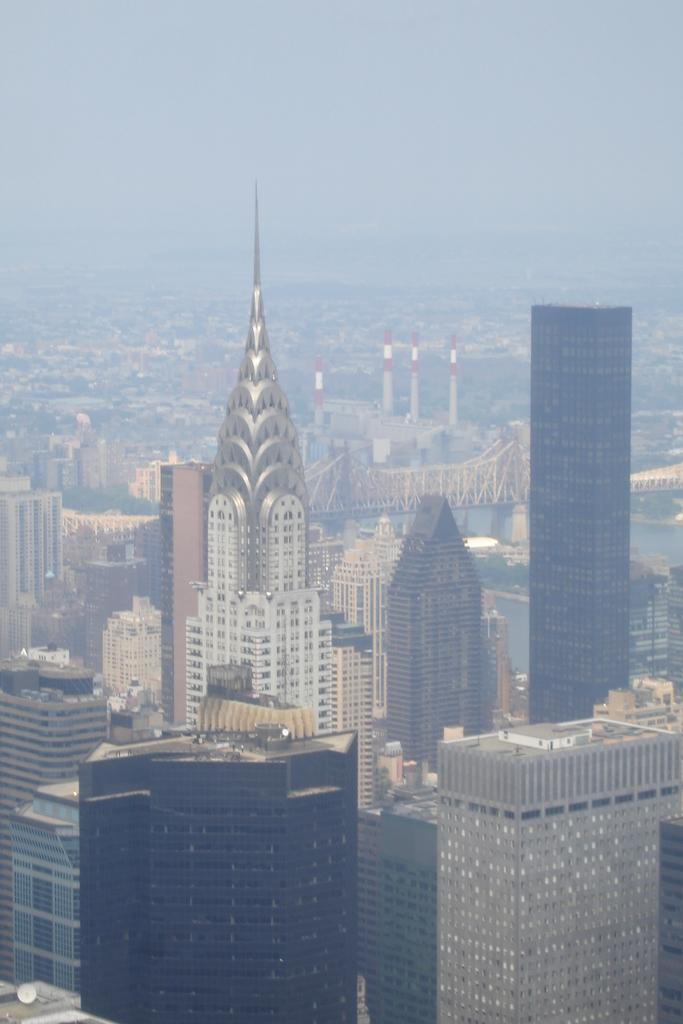What type of structures are visible in the image? There is a group of buildings with windows in the image. What can be seen in the center of the image? There is a bridge and towers in the center of the image. What is present in the center of the image along with the bridge and towers? There is water in the center of the image. What is visible at the top of the image? The sky is visible at the top of the image. What type of pest can be seen crawling on the buildings in the image? There is no pest visible in the image; the buildings are not infested with any creatures. How does the behavior of the towers change throughout the day in the image? The towers do not exhibit any behavior in the image, as they are stationary structures. 